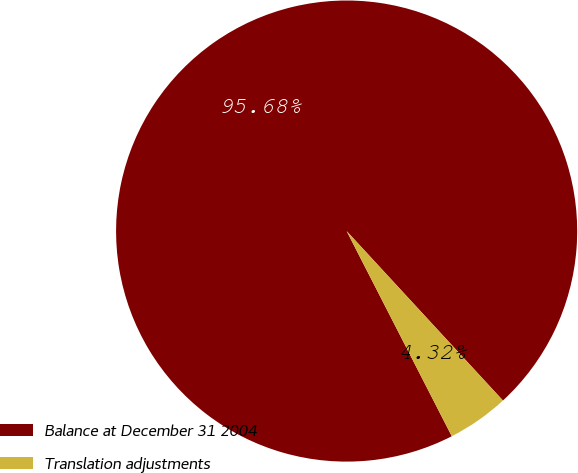Convert chart to OTSL. <chart><loc_0><loc_0><loc_500><loc_500><pie_chart><fcel>Balance at December 31 2004<fcel>Translation adjustments<nl><fcel>95.68%<fcel>4.32%<nl></chart> 